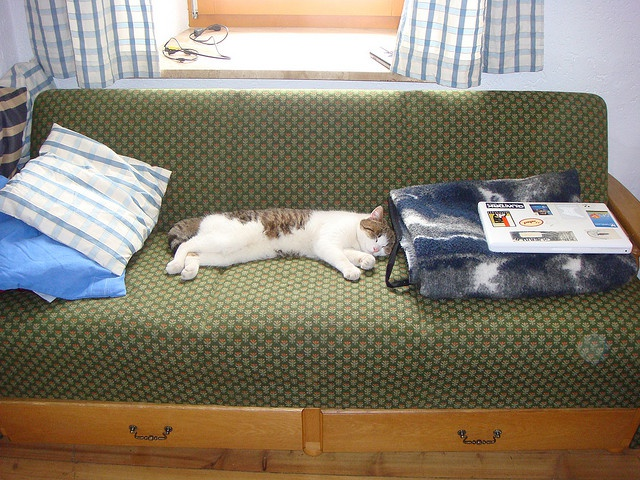Describe the objects in this image and their specific colors. I can see couch in darkgray, gray, darkgreen, black, and lightgray tones, cat in darkgray, lightgray, and gray tones, and book in darkgray, lightgray, gray, and black tones in this image. 